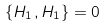<formula> <loc_0><loc_0><loc_500><loc_500>\{ H _ { 1 } , H _ { 1 } \} = 0</formula> 